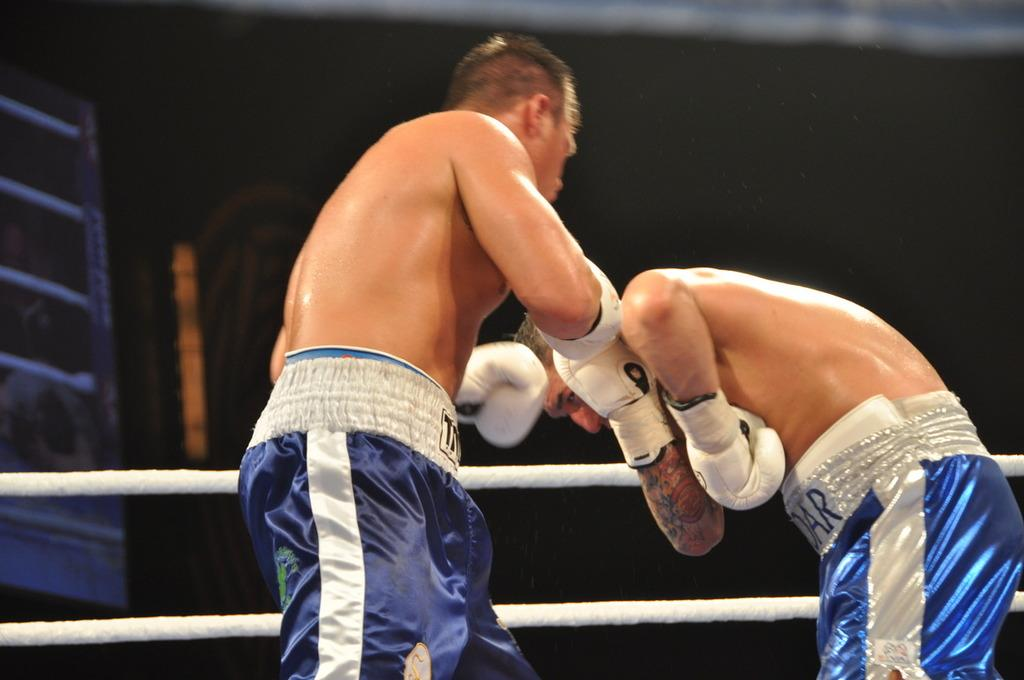How many people are in the image? There are two persons in the image. What are the persons wearing on their hands? Both persons are wearing gloves. Can you describe any distinguishing features on one of the person's hands? There is a tattoo on one person's hand. What can be seen in the background of the image? There are ropes visible in the background of the image. How would you describe the overall lighting or color of the background? The background has a dark view. What type of apple is being used as a hobby in the image? There is no apple present in the image, and no hobbies are being depicted. 